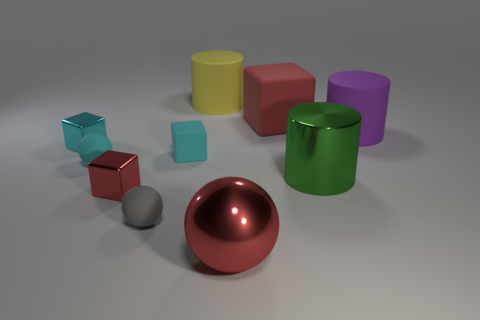What material is the large purple cylinder?
Ensure brevity in your answer.  Rubber. Is there any other thing of the same color as the metallic cylinder?
Give a very brief answer. No. Is the yellow matte thing the same shape as the cyan shiny object?
Make the answer very short. No. What is the size of the red cube in front of the small metal thing that is to the left of the small matte sphere behind the tiny gray matte ball?
Your answer should be compact. Small. What number of other things are there of the same material as the big purple object
Your answer should be compact. 5. The big rubber cylinder right of the red matte cube is what color?
Your answer should be very brief. Purple. What material is the tiny block on the left side of the red cube that is left of the red metal object on the right side of the yellow thing made of?
Give a very brief answer. Metal. Are there any other large shiny objects of the same shape as the big yellow object?
Ensure brevity in your answer.  Yes. The green object that is the same size as the red ball is what shape?
Give a very brief answer. Cylinder. How many things are both right of the large yellow cylinder and in front of the cyan metallic thing?
Give a very brief answer. 2. 